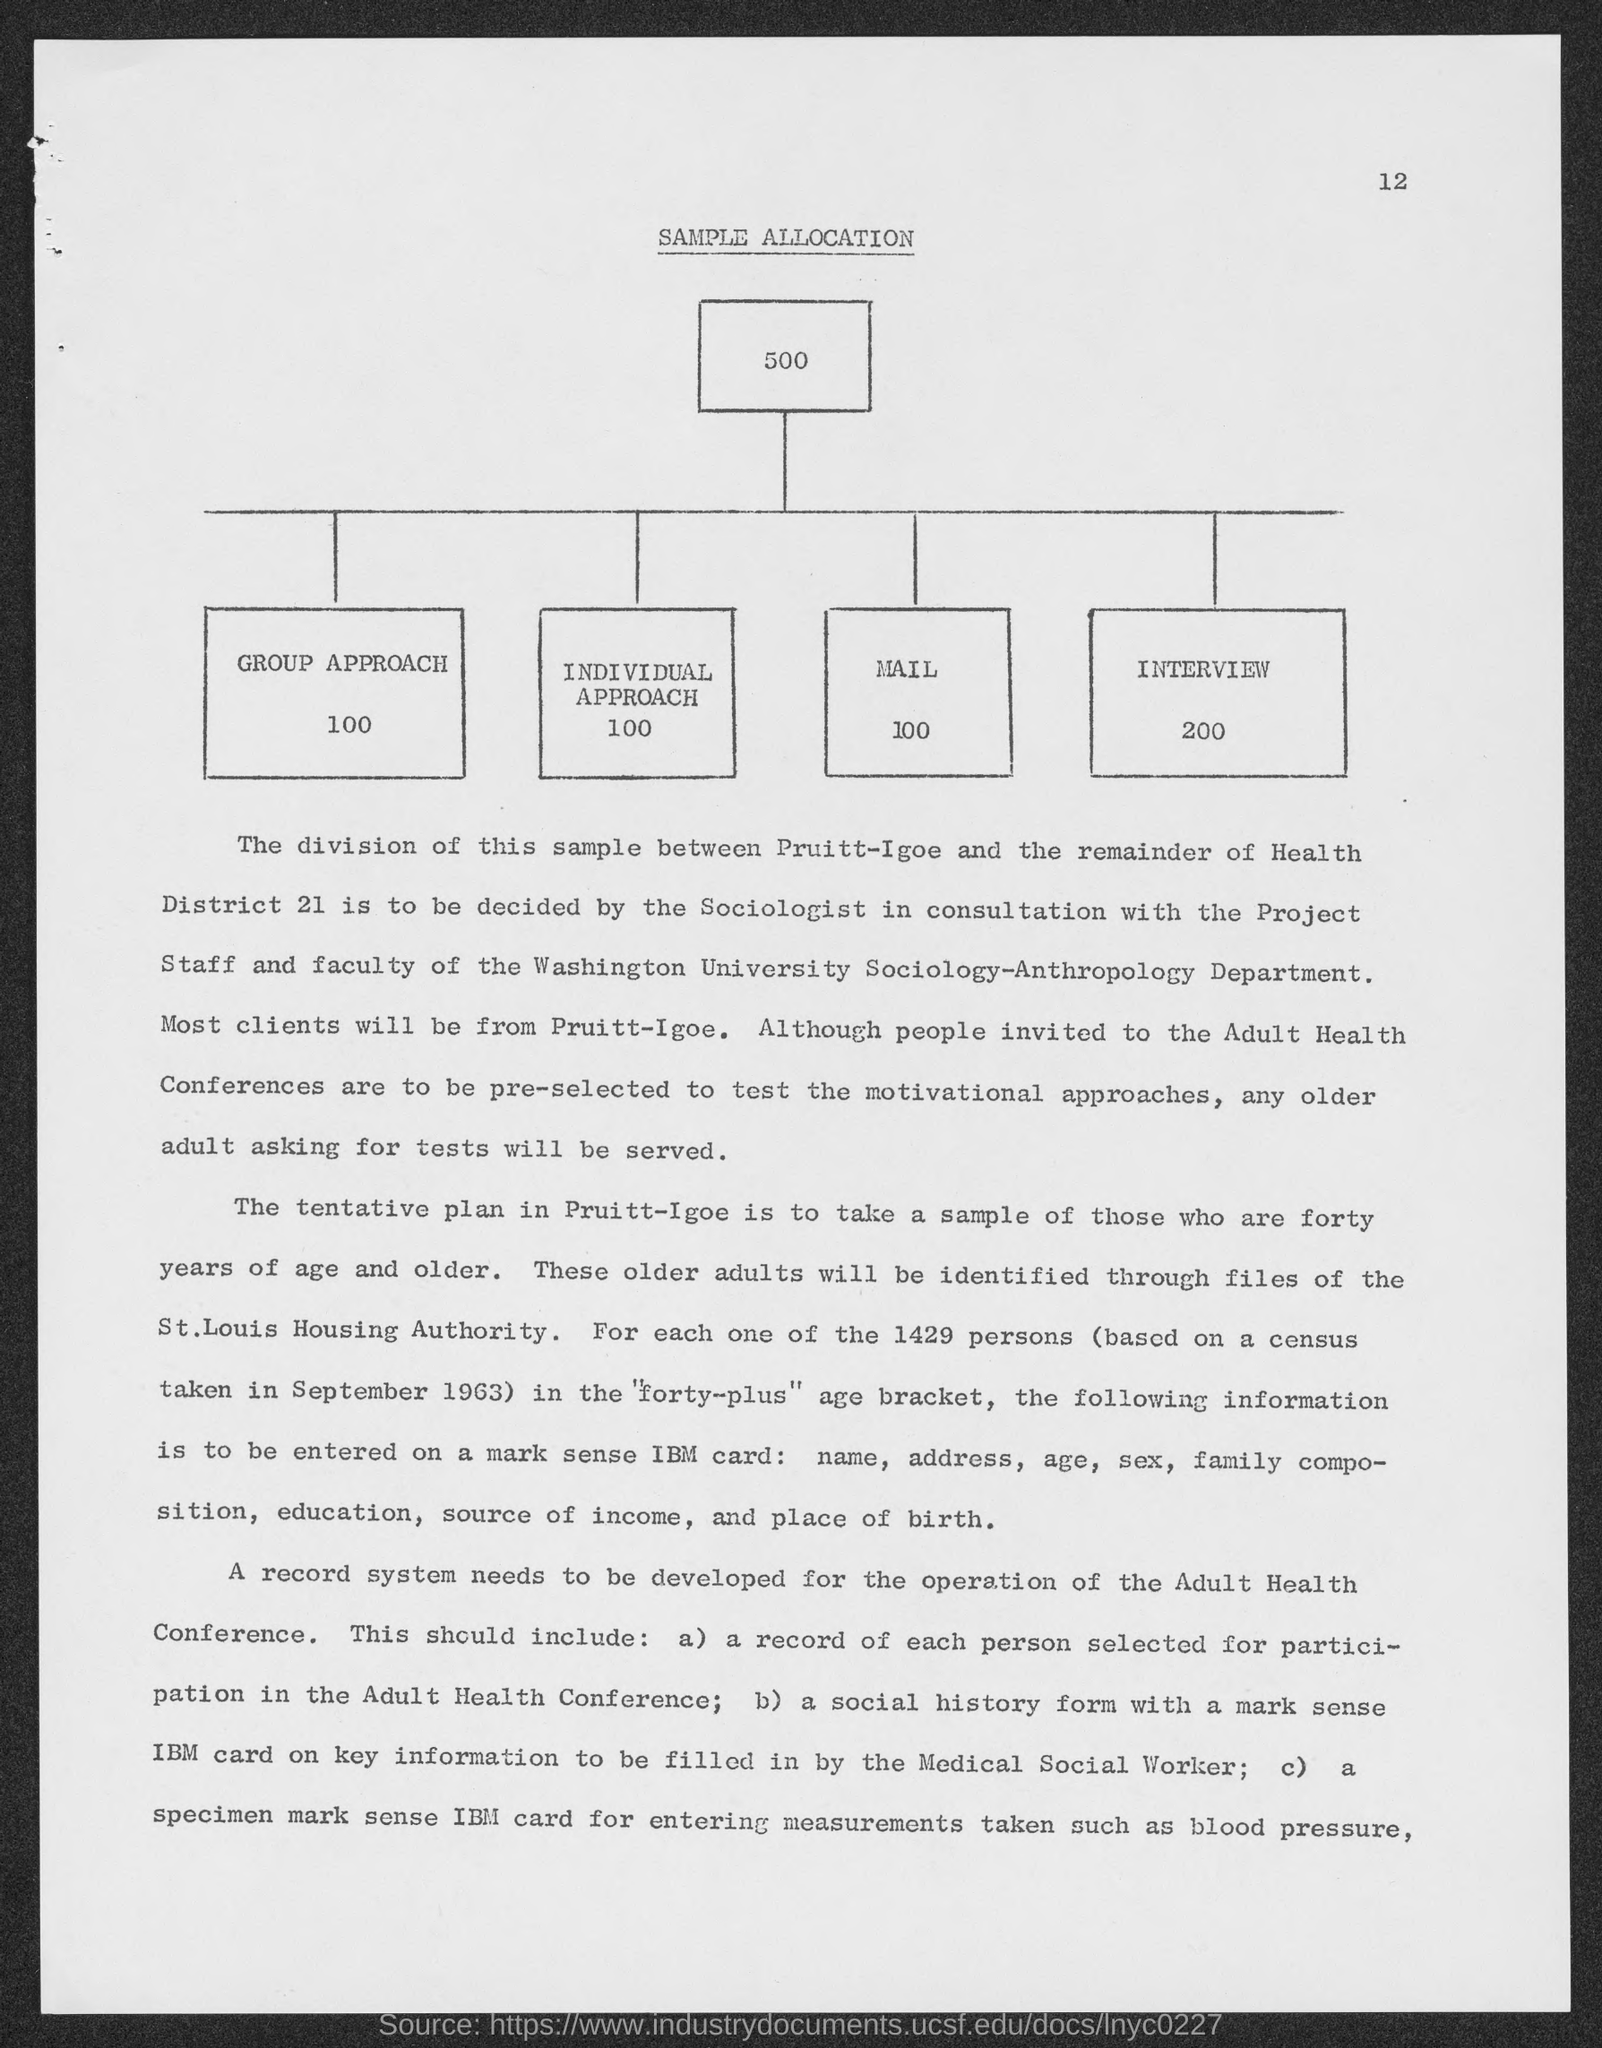Identify some key points in this picture. The page number is 12. There were 200 interviews conducted. There are 100 different group approaches. There were 100 individual approaches. The title of the document is 'sample allocation.' 